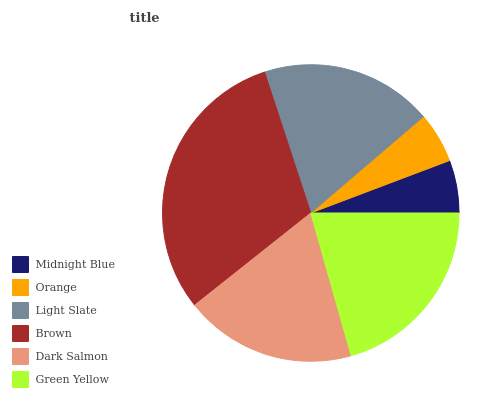Is Orange the minimum?
Answer yes or no. Yes. Is Brown the maximum?
Answer yes or no. Yes. Is Light Slate the minimum?
Answer yes or no. No. Is Light Slate the maximum?
Answer yes or no. No. Is Light Slate greater than Orange?
Answer yes or no. Yes. Is Orange less than Light Slate?
Answer yes or no. Yes. Is Orange greater than Light Slate?
Answer yes or no. No. Is Light Slate less than Orange?
Answer yes or no. No. Is Light Slate the high median?
Answer yes or no. Yes. Is Dark Salmon the low median?
Answer yes or no. Yes. Is Green Yellow the high median?
Answer yes or no. No. Is Midnight Blue the low median?
Answer yes or no. No. 